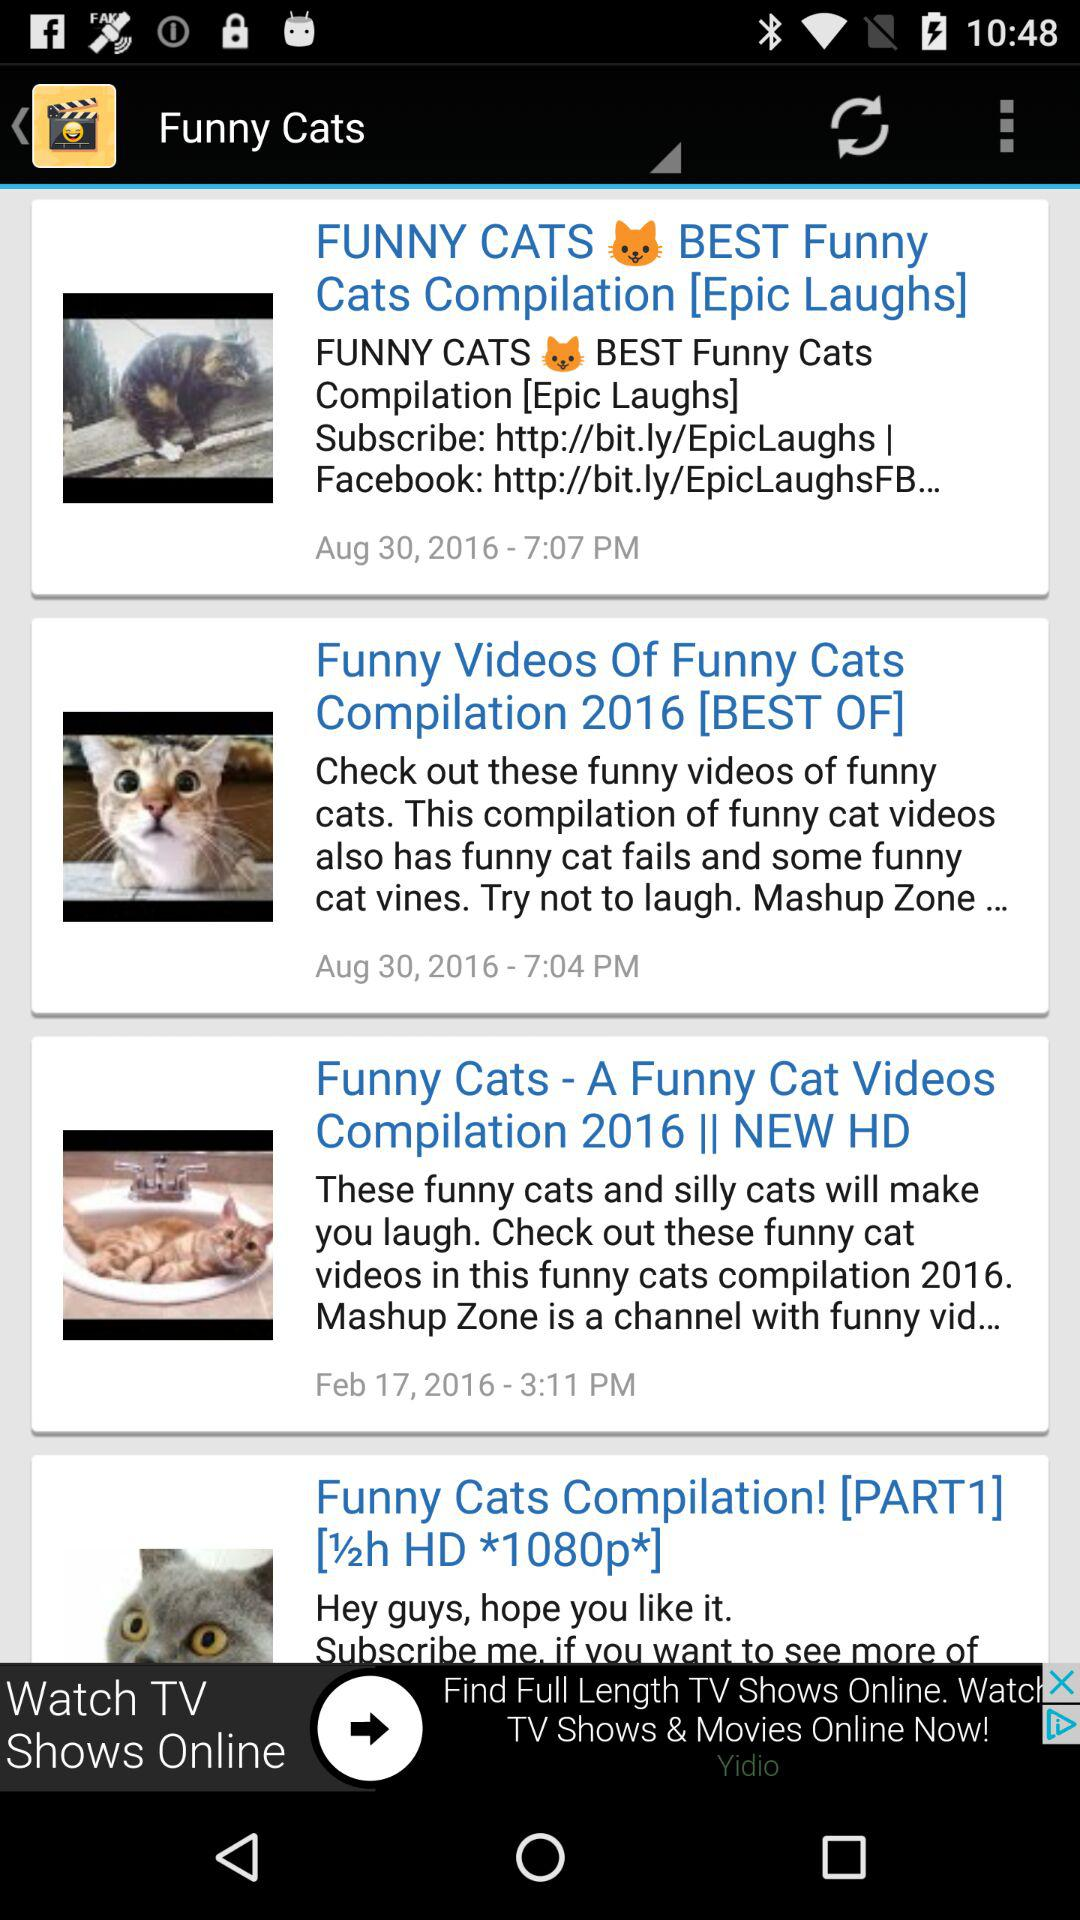What is the title of the post posted on August 30, 2016 at 7:04 p.m.? The title of the post posted on August 30, 2016 at 7:04 p.m. is "Funny Videos Of Funny Cats Compilation 2016 [BEST OF]". 